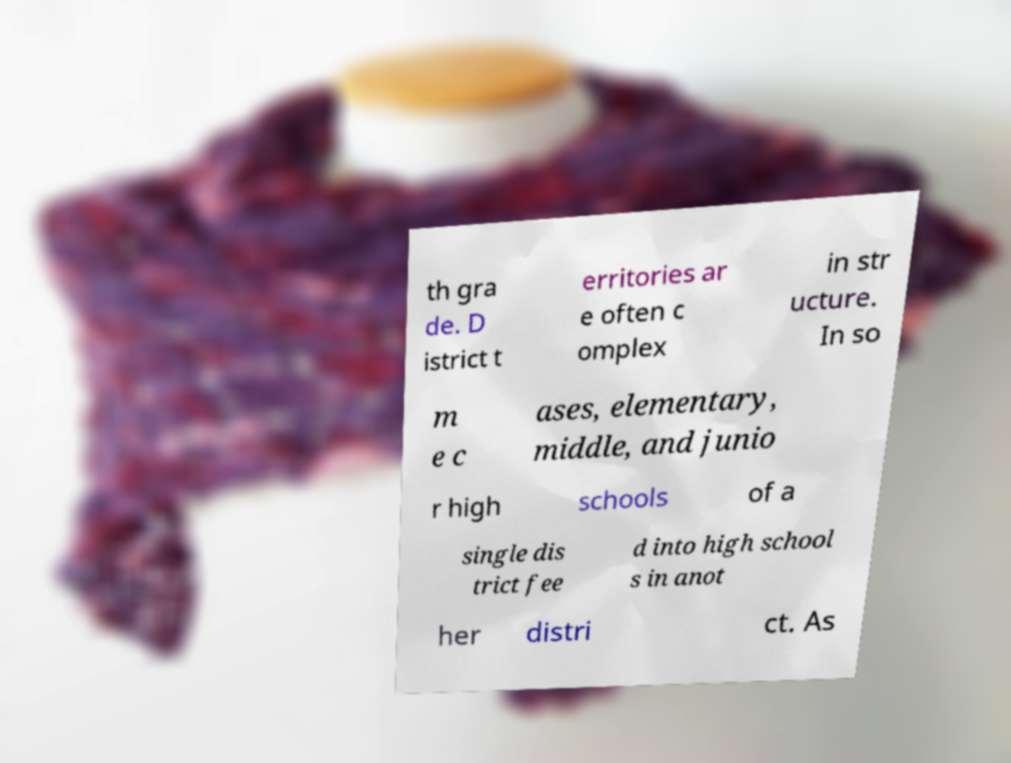Please read and relay the text visible in this image. What does it say? th gra de. D istrict t erritories ar e often c omplex in str ucture. In so m e c ases, elementary, middle, and junio r high schools of a single dis trict fee d into high school s in anot her distri ct. As 